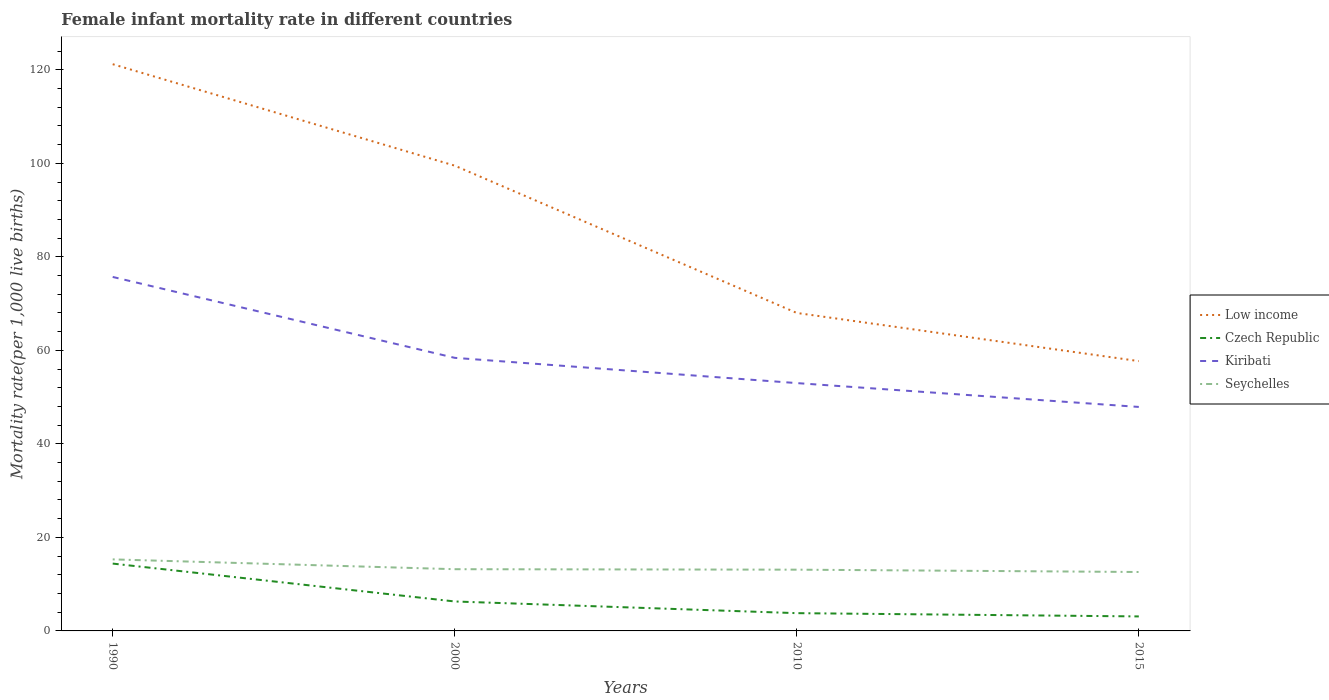Does the line corresponding to Low income intersect with the line corresponding to Kiribati?
Your answer should be compact. No. Is the number of lines equal to the number of legend labels?
Give a very brief answer. Yes. Across all years, what is the maximum female infant mortality rate in Low income?
Offer a very short reply. 57.7. In which year was the female infant mortality rate in Kiribati maximum?
Your answer should be compact. 2015. What is the total female infant mortality rate in Low income in the graph?
Provide a short and direct response. 10.3. What is the difference between the highest and the second highest female infant mortality rate in Seychelles?
Offer a very short reply. 2.7. What is the difference between the highest and the lowest female infant mortality rate in Seychelles?
Your answer should be very brief. 1. Is the female infant mortality rate in Seychelles strictly greater than the female infant mortality rate in Czech Republic over the years?
Give a very brief answer. No. Are the values on the major ticks of Y-axis written in scientific E-notation?
Offer a terse response. No. Does the graph contain any zero values?
Keep it short and to the point. No. Does the graph contain grids?
Provide a succinct answer. No. How many legend labels are there?
Offer a very short reply. 4. What is the title of the graph?
Offer a very short reply. Female infant mortality rate in different countries. What is the label or title of the Y-axis?
Your answer should be very brief. Mortality rate(per 1,0 live births). What is the Mortality rate(per 1,000 live births) of Low income in 1990?
Offer a terse response. 121.2. What is the Mortality rate(per 1,000 live births) in Czech Republic in 1990?
Offer a very short reply. 14.4. What is the Mortality rate(per 1,000 live births) in Kiribati in 1990?
Offer a terse response. 75.7. What is the Mortality rate(per 1,000 live births) of Seychelles in 1990?
Provide a short and direct response. 15.3. What is the Mortality rate(per 1,000 live births) of Low income in 2000?
Offer a terse response. 99.5. What is the Mortality rate(per 1,000 live births) in Kiribati in 2000?
Keep it short and to the point. 58.4. What is the Mortality rate(per 1,000 live births) in Seychelles in 2000?
Offer a very short reply. 13.2. What is the Mortality rate(per 1,000 live births) in Czech Republic in 2010?
Provide a short and direct response. 3.8. What is the Mortality rate(per 1,000 live births) in Kiribati in 2010?
Offer a terse response. 53. What is the Mortality rate(per 1,000 live births) of Seychelles in 2010?
Provide a succinct answer. 13.1. What is the Mortality rate(per 1,000 live births) in Low income in 2015?
Your response must be concise. 57.7. What is the Mortality rate(per 1,000 live births) in Kiribati in 2015?
Keep it short and to the point. 47.9. Across all years, what is the maximum Mortality rate(per 1,000 live births) in Low income?
Make the answer very short. 121.2. Across all years, what is the maximum Mortality rate(per 1,000 live births) of Czech Republic?
Offer a very short reply. 14.4. Across all years, what is the maximum Mortality rate(per 1,000 live births) of Kiribati?
Make the answer very short. 75.7. Across all years, what is the maximum Mortality rate(per 1,000 live births) in Seychelles?
Offer a very short reply. 15.3. Across all years, what is the minimum Mortality rate(per 1,000 live births) in Low income?
Your answer should be very brief. 57.7. Across all years, what is the minimum Mortality rate(per 1,000 live births) in Kiribati?
Provide a short and direct response. 47.9. What is the total Mortality rate(per 1,000 live births) of Low income in the graph?
Your response must be concise. 346.4. What is the total Mortality rate(per 1,000 live births) of Czech Republic in the graph?
Make the answer very short. 27.6. What is the total Mortality rate(per 1,000 live births) in Kiribati in the graph?
Keep it short and to the point. 235. What is the total Mortality rate(per 1,000 live births) in Seychelles in the graph?
Keep it short and to the point. 54.2. What is the difference between the Mortality rate(per 1,000 live births) in Low income in 1990 and that in 2000?
Provide a succinct answer. 21.7. What is the difference between the Mortality rate(per 1,000 live births) of Czech Republic in 1990 and that in 2000?
Give a very brief answer. 8.1. What is the difference between the Mortality rate(per 1,000 live births) in Low income in 1990 and that in 2010?
Provide a short and direct response. 53.2. What is the difference between the Mortality rate(per 1,000 live births) of Czech Republic in 1990 and that in 2010?
Keep it short and to the point. 10.6. What is the difference between the Mortality rate(per 1,000 live births) of Kiribati in 1990 and that in 2010?
Your answer should be very brief. 22.7. What is the difference between the Mortality rate(per 1,000 live births) in Low income in 1990 and that in 2015?
Your answer should be compact. 63.5. What is the difference between the Mortality rate(per 1,000 live births) in Czech Republic in 1990 and that in 2015?
Your response must be concise. 11.3. What is the difference between the Mortality rate(per 1,000 live births) of Kiribati in 1990 and that in 2015?
Keep it short and to the point. 27.8. What is the difference between the Mortality rate(per 1,000 live births) in Seychelles in 1990 and that in 2015?
Ensure brevity in your answer.  2.7. What is the difference between the Mortality rate(per 1,000 live births) in Low income in 2000 and that in 2010?
Give a very brief answer. 31.5. What is the difference between the Mortality rate(per 1,000 live births) in Kiribati in 2000 and that in 2010?
Make the answer very short. 5.4. What is the difference between the Mortality rate(per 1,000 live births) of Low income in 2000 and that in 2015?
Make the answer very short. 41.8. What is the difference between the Mortality rate(per 1,000 live births) in Czech Republic in 2000 and that in 2015?
Offer a terse response. 3.2. What is the difference between the Mortality rate(per 1,000 live births) of Kiribati in 2000 and that in 2015?
Offer a terse response. 10.5. What is the difference between the Mortality rate(per 1,000 live births) of Low income in 2010 and that in 2015?
Ensure brevity in your answer.  10.3. What is the difference between the Mortality rate(per 1,000 live births) in Kiribati in 2010 and that in 2015?
Your answer should be very brief. 5.1. What is the difference between the Mortality rate(per 1,000 live births) in Seychelles in 2010 and that in 2015?
Give a very brief answer. 0.5. What is the difference between the Mortality rate(per 1,000 live births) in Low income in 1990 and the Mortality rate(per 1,000 live births) in Czech Republic in 2000?
Give a very brief answer. 114.9. What is the difference between the Mortality rate(per 1,000 live births) in Low income in 1990 and the Mortality rate(per 1,000 live births) in Kiribati in 2000?
Give a very brief answer. 62.8. What is the difference between the Mortality rate(per 1,000 live births) in Low income in 1990 and the Mortality rate(per 1,000 live births) in Seychelles in 2000?
Your answer should be compact. 108. What is the difference between the Mortality rate(per 1,000 live births) in Czech Republic in 1990 and the Mortality rate(per 1,000 live births) in Kiribati in 2000?
Keep it short and to the point. -44. What is the difference between the Mortality rate(per 1,000 live births) of Czech Republic in 1990 and the Mortality rate(per 1,000 live births) of Seychelles in 2000?
Offer a terse response. 1.2. What is the difference between the Mortality rate(per 1,000 live births) in Kiribati in 1990 and the Mortality rate(per 1,000 live births) in Seychelles in 2000?
Ensure brevity in your answer.  62.5. What is the difference between the Mortality rate(per 1,000 live births) in Low income in 1990 and the Mortality rate(per 1,000 live births) in Czech Republic in 2010?
Make the answer very short. 117.4. What is the difference between the Mortality rate(per 1,000 live births) in Low income in 1990 and the Mortality rate(per 1,000 live births) in Kiribati in 2010?
Your answer should be very brief. 68.2. What is the difference between the Mortality rate(per 1,000 live births) of Low income in 1990 and the Mortality rate(per 1,000 live births) of Seychelles in 2010?
Your answer should be compact. 108.1. What is the difference between the Mortality rate(per 1,000 live births) of Czech Republic in 1990 and the Mortality rate(per 1,000 live births) of Kiribati in 2010?
Offer a very short reply. -38.6. What is the difference between the Mortality rate(per 1,000 live births) of Czech Republic in 1990 and the Mortality rate(per 1,000 live births) of Seychelles in 2010?
Provide a short and direct response. 1.3. What is the difference between the Mortality rate(per 1,000 live births) of Kiribati in 1990 and the Mortality rate(per 1,000 live births) of Seychelles in 2010?
Provide a succinct answer. 62.6. What is the difference between the Mortality rate(per 1,000 live births) of Low income in 1990 and the Mortality rate(per 1,000 live births) of Czech Republic in 2015?
Your answer should be very brief. 118.1. What is the difference between the Mortality rate(per 1,000 live births) in Low income in 1990 and the Mortality rate(per 1,000 live births) in Kiribati in 2015?
Your response must be concise. 73.3. What is the difference between the Mortality rate(per 1,000 live births) of Low income in 1990 and the Mortality rate(per 1,000 live births) of Seychelles in 2015?
Keep it short and to the point. 108.6. What is the difference between the Mortality rate(per 1,000 live births) of Czech Republic in 1990 and the Mortality rate(per 1,000 live births) of Kiribati in 2015?
Give a very brief answer. -33.5. What is the difference between the Mortality rate(per 1,000 live births) of Kiribati in 1990 and the Mortality rate(per 1,000 live births) of Seychelles in 2015?
Make the answer very short. 63.1. What is the difference between the Mortality rate(per 1,000 live births) of Low income in 2000 and the Mortality rate(per 1,000 live births) of Czech Republic in 2010?
Your answer should be compact. 95.7. What is the difference between the Mortality rate(per 1,000 live births) in Low income in 2000 and the Mortality rate(per 1,000 live births) in Kiribati in 2010?
Provide a succinct answer. 46.5. What is the difference between the Mortality rate(per 1,000 live births) in Low income in 2000 and the Mortality rate(per 1,000 live births) in Seychelles in 2010?
Offer a terse response. 86.4. What is the difference between the Mortality rate(per 1,000 live births) of Czech Republic in 2000 and the Mortality rate(per 1,000 live births) of Kiribati in 2010?
Your answer should be very brief. -46.7. What is the difference between the Mortality rate(per 1,000 live births) of Kiribati in 2000 and the Mortality rate(per 1,000 live births) of Seychelles in 2010?
Your answer should be very brief. 45.3. What is the difference between the Mortality rate(per 1,000 live births) in Low income in 2000 and the Mortality rate(per 1,000 live births) in Czech Republic in 2015?
Offer a terse response. 96.4. What is the difference between the Mortality rate(per 1,000 live births) in Low income in 2000 and the Mortality rate(per 1,000 live births) in Kiribati in 2015?
Offer a terse response. 51.6. What is the difference between the Mortality rate(per 1,000 live births) in Low income in 2000 and the Mortality rate(per 1,000 live births) in Seychelles in 2015?
Provide a succinct answer. 86.9. What is the difference between the Mortality rate(per 1,000 live births) of Czech Republic in 2000 and the Mortality rate(per 1,000 live births) of Kiribati in 2015?
Give a very brief answer. -41.6. What is the difference between the Mortality rate(per 1,000 live births) in Czech Republic in 2000 and the Mortality rate(per 1,000 live births) in Seychelles in 2015?
Your answer should be very brief. -6.3. What is the difference between the Mortality rate(per 1,000 live births) of Kiribati in 2000 and the Mortality rate(per 1,000 live births) of Seychelles in 2015?
Your answer should be very brief. 45.8. What is the difference between the Mortality rate(per 1,000 live births) of Low income in 2010 and the Mortality rate(per 1,000 live births) of Czech Republic in 2015?
Your answer should be compact. 64.9. What is the difference between the Mortality rate(per 1,000 live births) of Low income in 2010 and the Mortality rate(per 1,000 live births) of Kiribati in 2015?
Your answer should be very brief. 20.1. What is the difference between the Mortality rate(per 1,000 live births) in Low income in 2010 and the Mortality rate(per 1,000 live births) in Seychelles in 2015?
Ensure brevity in your answer.  55.4. What is the difference between the Mortality rate(per 1,000 live births) in Czech Republic in 2010 and the Mortality rate(per 1,000 live births) in Kiribati in 2015?
Your answer should be very brief. -44.1. What is the difference between the Mortality rate(per 1,000 live births) in Kiribati in 2010 and the Mortality rate(per 1,000 live births) in Seychelles in 2015?
Your response must be concise. 40.4. What is the average Mortality rate(per 1,000 live births) in Low income per year?
Offer a very short reply. 86.6. What is the average Mortality rate(per 1,000 live births) of Kiribati per year?
Ensure brevity in your answer.  58.75. What is the average Mortality rate(per 1,000 live births) in Seychelles per year?
Your answer should be very brief. 13.55. In the year 1990, what is the difference between the Mortality rate(per 1,000 live births) of Low income and Mortality rate(per 1,000 live births) of Czech Republic?
Offer a terse response. 106.8. In the year 1990, what is the difference between the Mortality rate(per 1,000 live births) of Low income and Mortality rate(per 1,000 live births) of Kiribati?
Make the answer very short. 45.5. In the year 1990, what is the difference between the Mortality rate(per 1,000 live births) in Low income and Mortality rate(per 1,000 live births) in Seychelles?
Offer a very short reply. 105.9. In the year 1990, what is the difference between the Mortality rate(per 1,000 live births) of Czech Republic and Mortality rate(per 1,000 live births) of Kiribati?
Provide a succinct answer. -61.3. In the year 1990, what is the difference between the Mortality rate(per 1,000 live births) of Kiribati and Mortality rate(per 1,000 live births) of Seychelles?
Offer a terse response. 60.4. In the year 2000, what is the difference between the Mortality rate(per 1,000 live births) of Low income and Mortality rate(per 1,000 live births) of Czech Republic?
Your response must be concise. 93.2. In the year 2000, what is the difference between the Mortality rate(per 1,000 live births) in Low income and Mortality rate(per 1,000 live births) in Kiribati?
Give a very brief answer. 41.1. In the year 2000, what is the difference between the Mortality rate(per 1,000 live births) in Low income and Mortality rate(per 1,000 live births) in Seychelles?
Ensure brevity in your answer.  86.3. In the year 2000, what is the difference between the Mortality rate(per 1,000 live births) in Czech Republic and Mortality rate(per 1,000 live births) in Kiribati?
Offer a very short reply. -52.1. In the year 2000, what is the difference between the Mortality rate(per 1,000 live births) in Kiribati and Mortality rate(per 1,000 live births) in Seychelles?
Give a very brief answer. 45.2. In the year 2010, what is the difference between the Mortality rate(per 1,000 live births) in Low income and Mortality rate(per 1,000 live births) in Czech Republic?
Your answer should be very brief. 64.2. In the year 2010, what is the difference between the Mortality rate(per 1,000 live births) of Low income and Mortality rate(per 1,000 live births) of Kiribati?
Your answer should be very brief. 15. In the year 2010, what is the difference between the Mortality rate(per 1,000 live births) in Low income and Mortality rate(per 1,000 live births) in Seychelles?
Provide a short and direct response. 54.9. In the year 2010, what is the difference between the Mortality rate(per 1,000 live births) of Czech Republic and Mortality rate(per 1,000 live births) of Kiribati?
Offer a terse response. -49.2. In the year 2010, what is the difference between the Mortality rate(per 1,000 live births) of Czech Republic and Mortality rate(per 1,000 live births) of Seychelles?
Your answer should be very brief. -9.3. In the year 2010, what is the difference between the Mortality rate(per 1,000 live births) in Kiribati and Mortality rate(per 1,000 live births) in Seychelles?
Provide a succinct answer. 39.9. In the year 2015, what is the difference between the Mortality rate(per 1,000 live births) of Low income and Mortality rate(per 1,000 live births) of Czech Republic?
Your answer should be compact. 54.6. In the year 2015, what is the difference between the Mortality rate(per 1,000 live births) in Low income and Mortality rate(per 1,000 live births) in Kiribati?
Ensure brevity in your answer.  9.8. In the year 2015, what is the difference between the Mortality rate(per 1,000 live births) of Low income and Mortality rate(per 1,000 live births) of Seychelles?
Keep it short and to the point. 45.1. In the year 2015, what is the difference between the Mortality rate(per 1,000 live births) of Czech Republic and Mortality rate(per 1,000 live births) of Kiribati?
Give a very brief answer. -44.8. In the year 2015, what is the difference between the Mortality rate(per 1,000 live births) in Czech Republic and Mortality rate(per 1,000 live births) in Seychelles?
Provide a succinct answer. -9.5. In the year 2015, what is the difference between the Mortality rate(per 1,000 live births) in Kiribati and Mortality rate(per 1,000 live births) in Seychelles?
Your answer should be compact. 35.3. What is the ratio of the Mortality rate(per 1,000 live births) in Low income in 1990 to that in 2000?
Your response must be concise. 1.22. What is the ratio of the Mortality rate(per 1,000 live births) in Czech Republic in 1990 to that in 2000?
Provide a succinct answer. 2.29. What is the ratio of the Mortality rate(per 1,000 live births) in Kiribati in 1990 to that in 2000?
Provide a short and direct response. 1.3. What is the ratio of the Mortality rate(per 1,000 live births) in Seychelles in 1990 to that in 2000?
Provide a short and direct response. 1.16. What is the ratio of the Mortality rate(per 1,000 live births) of Low income in 1990 to that in 2010?
Keep it short and to the point. 1.78. What is the ratio of the Mortality rate(per 1,000 live births) in Czech Republic in 1990 to that in 2010?
Your answer should be very brief. 3.79. What is the ratio of the Mortality rate(per 1,000 live births) in Kiribati in 1990 to that in 2010?
Your answer should be very brief. 1.43. What is the ratio of the Mortality rate(per 1,000 live births) of Seychelles in 1990 to that in 2010?
Provide a succinct answer. 1.17. What is the ratio of the Mortality rate(per 1,000 live births) of Low income in 1990 to that in 2015?
Your response must be concise. 2.1. What is the ratio of the Mortality rate(per 1,000 live births) of Czech Republic in 1990 to that in 2015?
Give a very brief answer. 4.65. What is the ratio of the Mortality rate(per 1,000 live births) of Kiribati in 1990 to that in 2015?
Make the answer very short. 1.58. What is the ratio of the Mortality rate(per 1,000 live births) in Seychelles in 1990 to that in 2015?
Your response must be concise. 1.21. What is the ratio of the Mortality rate(per 1,000 live births) of Low income in 2000 to that in 2010?
Your response must be concise. 1.46. What is the ratio of the Mortality rate(per 1,000 live births) in Czech Republic in 2000 to that in 2010?
Keep it short and to the point. 1.66. What is the ratio of the Mortality rate(per 1,000 live births) of Kiribati in 2000 to that in 2010?
Offer a terse response. 1.1. What is the ratio of the Mortality rate(per 1,000 live births) of Seychelles in 2000 to that in 2010?
Ensure brevity in your answer.  1.01. What is the ratio of the Mortality rate(per 1,000 live births) in Low income in 2000 to that in 2015?
Ensure brevity in your answer.  1.72. What is the ratio of the Mortality rate(per 1,000 live births) of Czech Republic in 2000 to that in 2015?
Keep it short and to the point. 2.03. What is the ratio of the Mortality rate(per 1,000 live births) of Kiribati in 2000 to that in 2015?
Offer a very short reply. 1.22. What is the ratio of the Mortality rate(per 1,000 live births) of Seychelles in 2000 to that in 2015?
Offer a terse response. 1.05. What is the ratio of the Mortality rate(per 1,000 live births) of Low income in 2010 to that in 2015?
Ensure brevity in your answer.  1.18. What is the ratio of the Mortality rate(per 1,000 live births) in Czech Republic in 2010 to that in 2015?
Provide a succinct answer. 1.23. What is the ratio of the Mortality rate(per 1,000 live births) of Kiribati in 2010 to that in 2015?
Your answer should be compact. 1.11. What is the ratio of the Mortality rate(per 1,000 live births) in Seychelles in 2010 to that in 2015?
Provide a succinct answer. 1.04. What is the difference between the highest and the second highest Mortality rate(per 1,000 live births) of Low income?
Your answer should be very brief. 21.7. What is the difference between the highest and the second highest Mortality rate(per 1,000 live births) in Kiribati?
Ensure brevity in your answer.  17.3. What is the difference between the highest and the second highest Mortality rate(per 1,000 live births) in Seychelles?
Your answer should be compact. 2.1. What is the difference between the highest and the lowest Mortality rate(per 1,000 live births) in Low income?
Provide a succinct answer. 63.5. What is the difference between the highest and the lowest Mortality rate(per 1,000 live births) of Kiribati?
Give a very brief answer. 27.8. What is the difference between the highest and the lowest Mortality rate(per 1,000 live births) of Seychelles?
Ensure brevity in your answer.  2.7. 